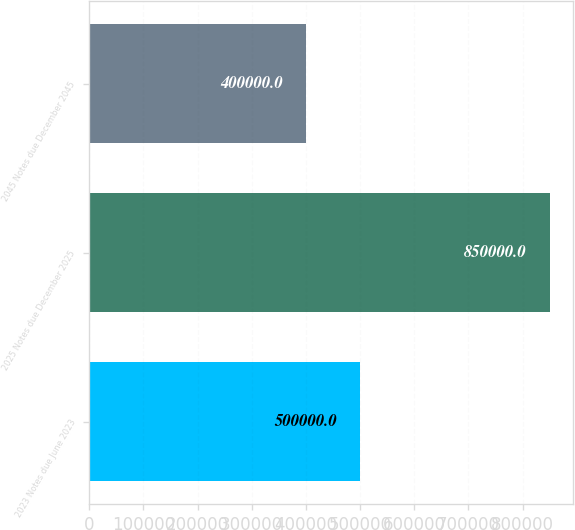Convert chart to OTSL. <chart><loc_0><loc_0><loc_500><loc_500><bar_chart><fcel>2023 Notes due June 2023<fcel>2025 Notes due December 2025<fcel>2045 Notes due December 2045<nl><fcel>500000<fcel>850000<fcel>400000<nl></chart> 